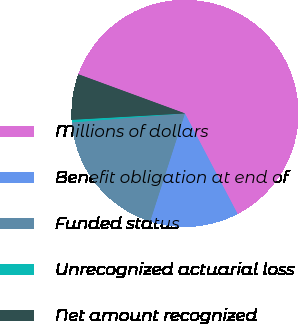<chart> <loc_0><loc_0><loc_500><loc_500><pie_chart><fcel>Millions of dollars<fcel>Benefit obligation at end of<fcel>Funded status<fcel>Unrecognized actuarial loss<fcel>Net amount recognized<nl><fcel>61.71%<fcel>12.64%<fcel>18.77%<fcel>0.37%<fcel>6.5%<nl></chart> 